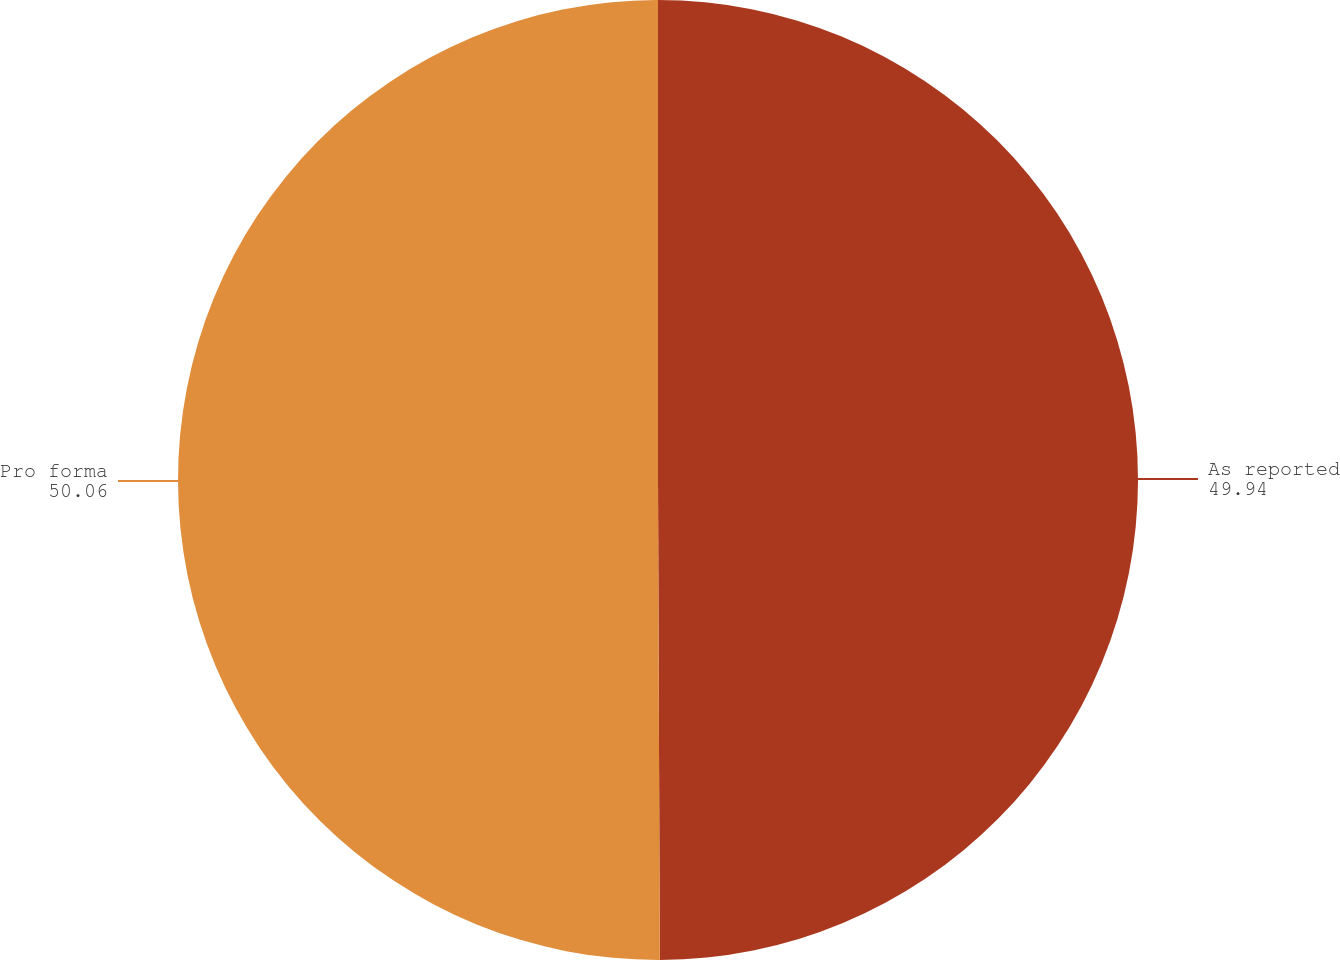<chart> <loc_0><loc_0><loc_500><loc_500><pie_chart><fcel>As reported<fcel>Pro forma<nl><fcel>49.94%<fcel>50.06%<nl></chart> 